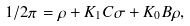<formula> <loc_0><loc_0><loc_500><loc_500>1 / 2 \pi = \rho + K _ { 1 } { C } \sigma + K _ { 0 } { B } \rho ,</formula> 